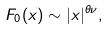Convert formula to latex. <formula><loc_0><loc_0><loc_500><loc_500>F _ { 0 } ( x ) \sim | x | ^ { \theta \nu } ,</formula> 